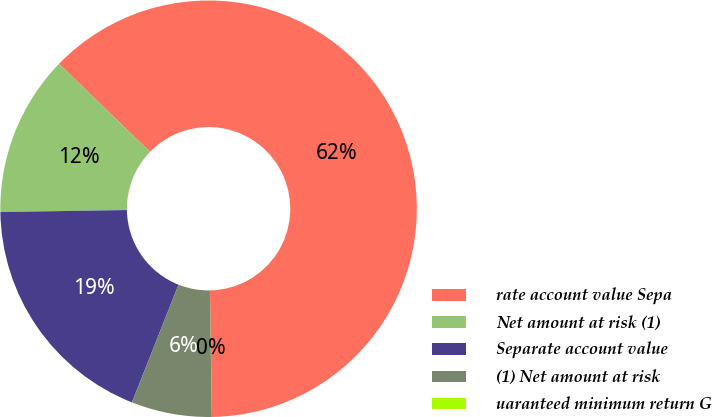Convert chart to OTSL. <chart><loc_0><loc_0><loc_500><loc_500><pie_chart><fcel>rate account value Sepa<fcel>Net amount at risk (1)<fcel>Separate account value<fcel>(1) Net amount at risk<fcel>uaranteed minimum return G<nl><fcel>62.49%<fcel>12.5%<fcel>18.75%<fcel>6.25%<fcel>0.01%<nl></chart> 